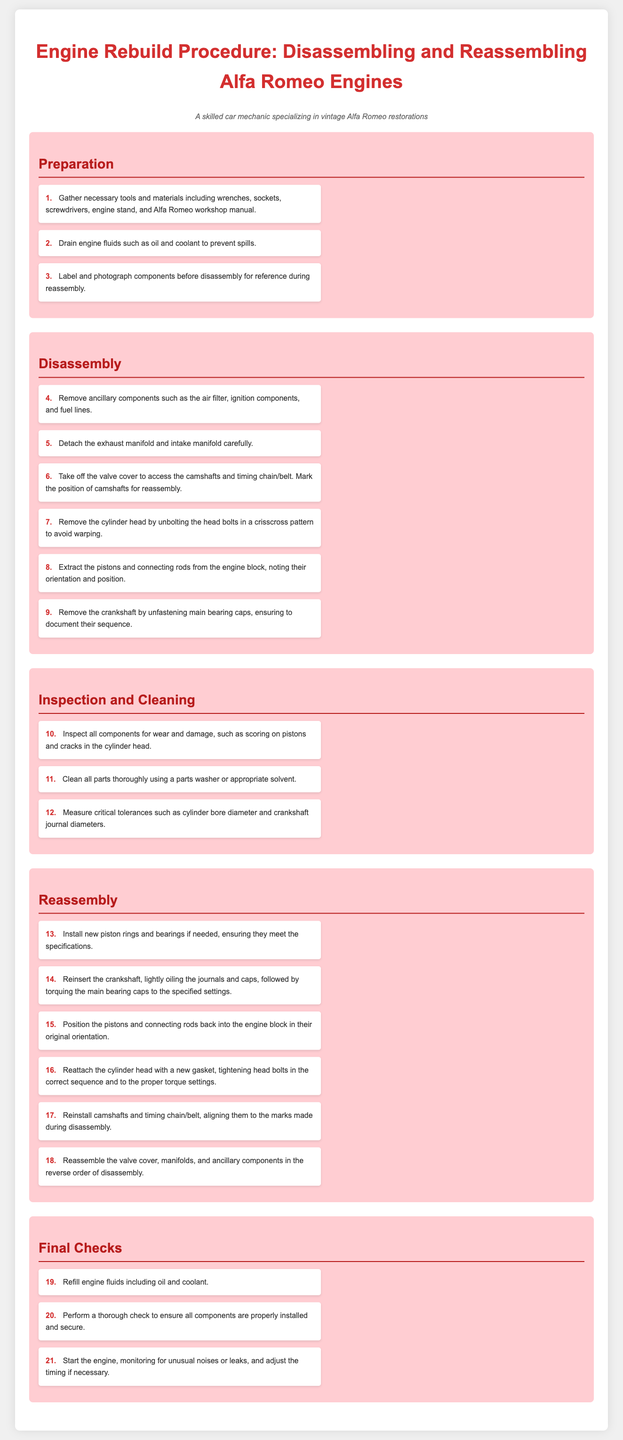What is the first step in the preparation section? The first step in the preparation section is to gather necessary tools and materials.
Answer: Gather necessary tools and materials including wrenches, sockets, screwdrivers, engine stand, and Alfa Romeo workshop manual How many steps are there in the disassembly section? The disassembly section contains a total of six steps listed.
Answer: Six steps What should you do before removing the cylinder head? Before removing the cylinder head, you should unbolt the head bolts in a crisscross pattern to avoid warping.
Answer: Unbolt the head bolts in a crisscross pattern to avoid warping What is the purpose of measuring tolerances? Measuring tolerances is crucial for ensuring parts are within acceptable specifications and fit properly during reassembly.
Answer: Ensuring parts are within acceptable specifications How should the cylinder head be reattached? The cylinder head should be reattached with a new gasket, tightening head bolts in the correct sequence and to the proper torque settings.
Answer: With a new gasket, tightening head bolts in the correct sequence and to the proper torque settings What is the last step in the final checks? The last step in the final checks is to start the engine and monitor for unusual noises or leaks.
Answer: Start the engine, monitoring for unusual noises or leaks What is the key document referenced for gathering information? The key document referenced is the Alfa Romeo workshop manual.
Answer: Alfa Romeo workshop manual What kind of components should be removed first in disassembly? Ancillary components should be removed first in the disassembly process.
Answer: Ancillary components 